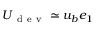Convert formula to latex. <formula><loc_0><loc_0><loc_500><loc_500>U _ { d e v } \simeq u _ { b } e _ { 1 }</formula> 